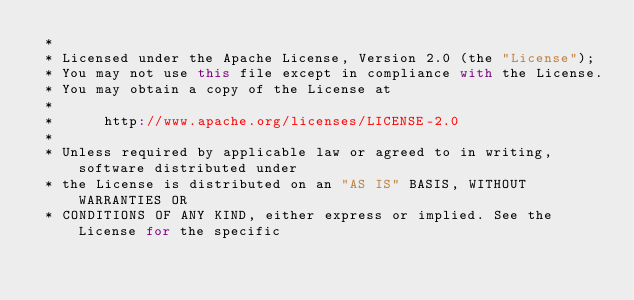<code> <loc_0><loc_0><loc_500><loc_500><_Scala_> *
 * Licensed under the Apache License, Version 2.0 (the "License");
 * You may not use this file except in compliance with the License.
 * You may obtain a copy of the License at
 *
 *      http://www.apache.org/licenses/LICENSE-2.0
 *
 * Unless required by applicable law or agreed to in writing, software distributed under
 * the License is distributed on an "AS IS" BASIS, WITHOUT WARRANTIES OR
 * CONDITIONS OF ANY KIND, either express or implied. See the License for the specific</code> 